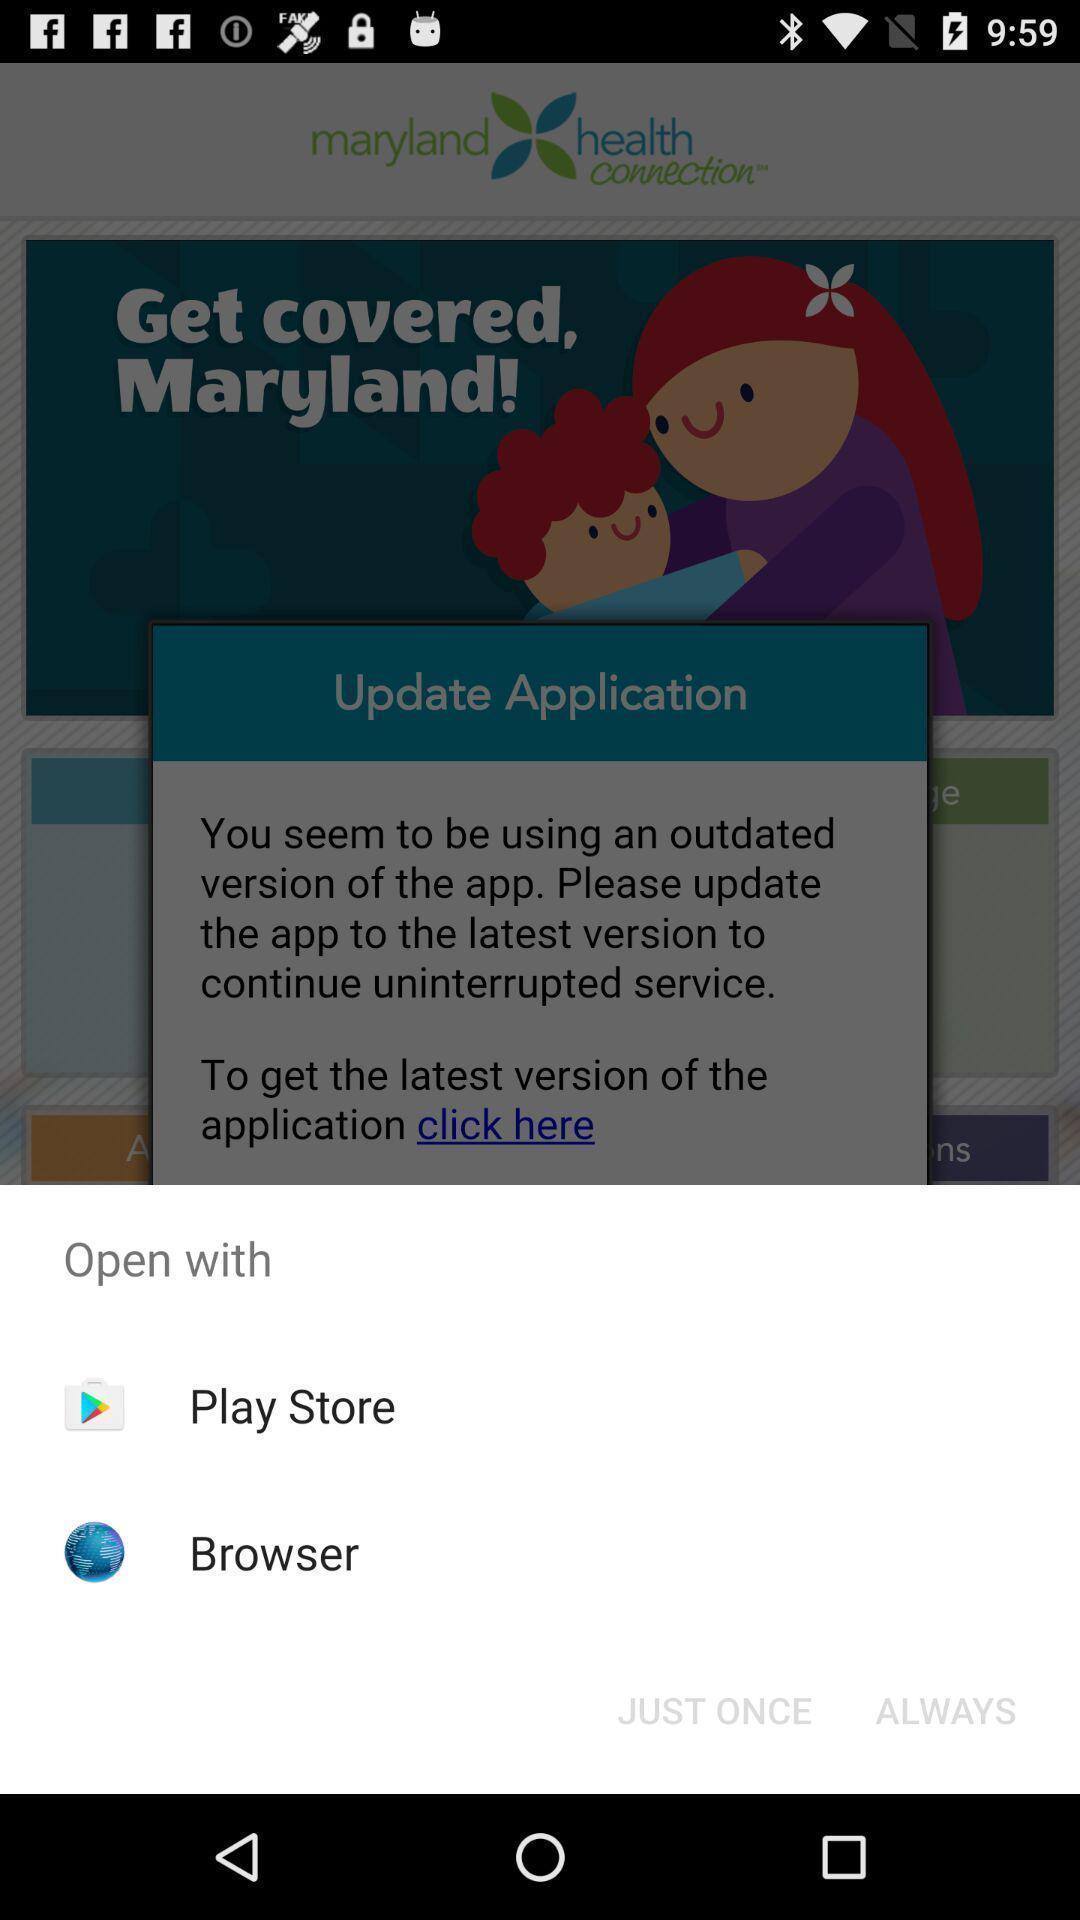What is the overall content of this screenshot? Popup displaying applications to open a file. 